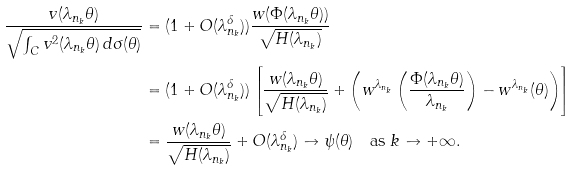Convert formula to latex. <formula><loc_0><loc_0><loc_500><loc_500>\frac { v ( \lambda _ { n _ { k } } \theta ) } { \sqrt { \int _ { C } v ^ { 2 } ( \lambda _ { n _ { k } } \theta ) \, d \sigma ( \theta ) } } & = ( 1 + O ( \lambda _ { n _ { k } } ^ { \delta } ) ) \frac { w ( \Phi ( \lambda _ { n _ { k } } \theta ) ) } { \sqrt { H ( \lambda _ { n _ { k } } ) } } \\ & = ( 1 + O ( \lambda _ { n _ { k } } ^ { \delta } ) ) \left [ \frac { w ( \lambda _ { n _ { k } } \theta ) } { \sqrt { H ( \lambda _ { n _ { k } } ) } } + \left ( w ^ { \lambda _ { n _ { k } } } \left ( \frac { \Phi ( \lambda _ { n _ { k } } \theta ) } { \lambda _ { n _ { k } } } \right ) - w ^ { \lambda _ { n _ { k } } } ( \theta ) \right ) \right ] \\ & = \frac { w ( \lambda _ { n _ { k } } \theta ) } { \sqrt { H ( \lambda _ { n _ { k } } ) } } + O ( \lambda _ { n _ { k } } ^ { \delta } ) \to \psi ( \theta ) \quad \text {as } k \to + \infty .</formula> 